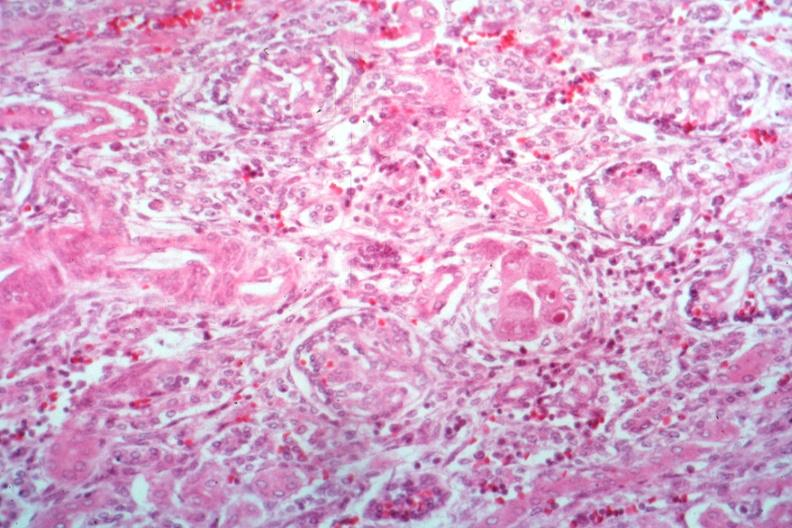s kidney present?
Answer the question using a single word or phrase. Yes 